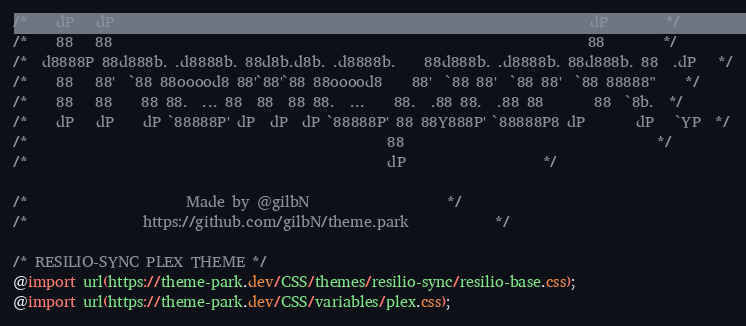<code> <loc_0><loc_0><loc_500><loc_500><_CSS_>
/*    dP   dP                                                                  dP        */
/*    88   88                                                                  88        */
/*  d8888P 88d888b. .d8888b. 88d8b.d8b. .d8888b.    88d888b. .d8888b. 88d888b. 88  .dP   */
/*    88   88'  `88 88ooood8 88'`88'`88 88ooood8    88'  `88 88'  `88 88'  `88 88888"    */
/*    88   88    88 88.  ... 88  88  88 88.  ...    88.  .88 88.  .88 88       88  `8b.  */
/*    dP   dP    dP `88888P' dP  dP  dP `88888P' 88 88Y888P' `88888P8 dP       dP   `YP  */
/*                                                  88                                   */
/*                                                  dP					 */

/*		   		        Made by @gilbN					 */
/* 			      https://github.com/gilbN/theme.park			 */

/* RESILIO-SYNC PLEX THEME */
@import url(https://theme-park.dev/CSS/themes/resilio-sync/resilio-base.css);
@import url(https://theme-park.dev/CSS/variables/plex.css);</code> 